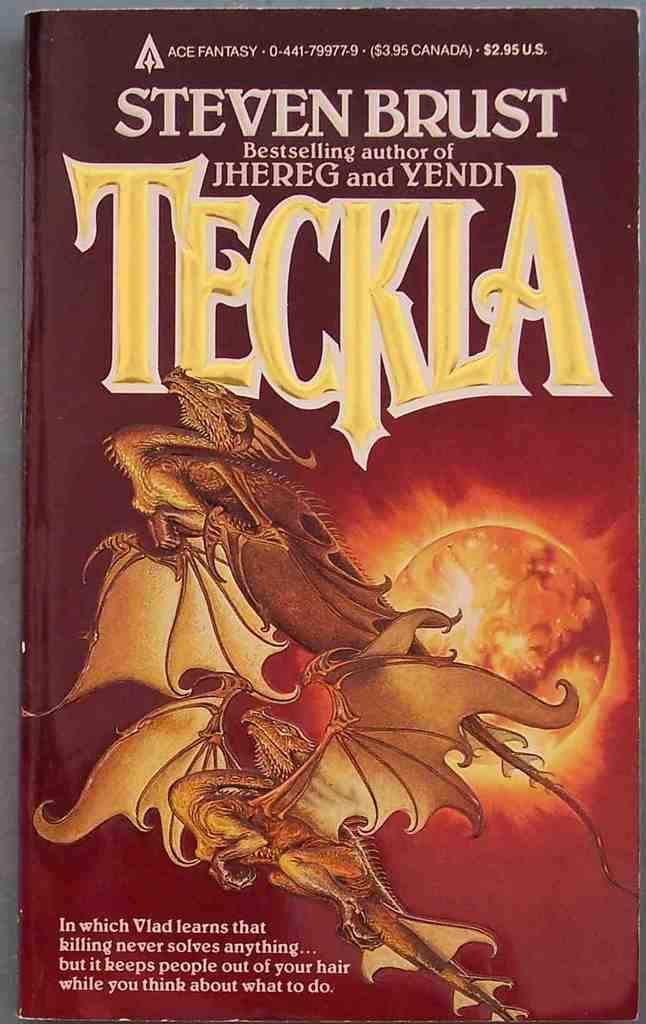<image>
Give a short and clear explanation of the subsequent image. Steven Brust's book Teckla who is the bestselling author if Yendi. 